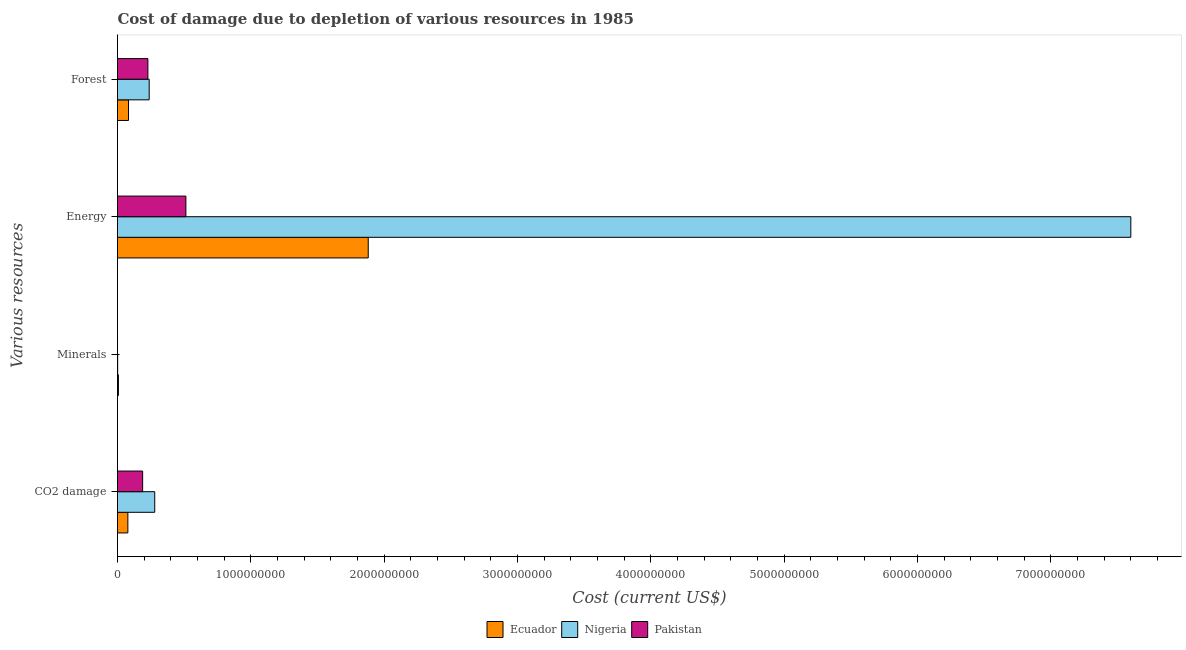How many different coloured bars are there?
Provide a succinct answer. 3. Are the number of bars per tick equal to the number of legend labels?
Your answer should be compact. Yes. Are the number of bars on each tick of the Y-axis equal?
Keep it short and to the point. Yes. What is the label of the 4th group of bars from the top?
Your answer should be very brief. CO2 damage. What is the cost of damage due to depletion of energy in Pakistan?
Offer a very short reply. 5.13e+08. Across all countries, what is the maximum cost of damage due to depletion of coal?
Your answer should be very brief. 2.79e+08. Across all countries, what is the minimum cost of damage due to depletion of forests?
Your answer should be compact. 8.26e+07. In which country was the cost of damage due to depletion of forests maximum?
Your answer should be very brief. Nigeria. What is the total cost of damage due to depletion of minerals in the graph?
Keep it short and to the point. 8.14e+06. What is the difference between the cost of damage due to depletion of minerals in Ecuador and that in Nigeria?
Offer a terse response. 5.61e+06. What is the difference between the cost of damage due to depletion of minerals in Pakistan and the cost of damage due to depletion of forests in Ecuador?
Give a very brief answer. -8.25e+07. What is the average cost of damage due to depletion of coal per country?
Provide a short and direct response. 1.82e+08. What is the difference between the cost of damage due to depletion of minerals and cost of damage due to depletion of forests in Nigeria?
Keep it short and to the point. -2.36e+08. In how many countries, is the cost of damage due to depletion of minerals greater than 2800000000 US$?
Keep it short and to the point. 0. What is the ratio of the cost of damage due to depletion of minerals in Ecuador to that in Nigeria?
Provide a short and direct response. 5.49. Is the cost of damage due to depletion of minerals in Nigeria less than that in Ecuador?
Provide a succinct answer. Yes. Is the difference between the cost of damage due to depletion of forests in Ecuador and Pakistan greater than the difference between the cost of damage due to depletion of minerals in Ecuador and Pakistan?
Provide a succinct answer. No. What is the difference between the highest and the second highest cost of damage due to depletion of minerals?
Provide a short and direct response. 5.61e+06. What is the difference between the highest and the lowest cost of damage due to depletion of energy?
Your response must be concise. 7.09e+09. In how many countries, is the cost of damage due to depletion of coal greater than the average cost of damage due to depletion of coal taken over all countries?
Your answer should be compact. 2. Is the sum of the cost of damage due to depletion of coal in Pakistan and Ecuador greater than the maximum cost of damage due to depletion of forests across all countries?
Your answer should be compact. Yes. Is it the case that in every country, the sum of the cost of damage due to depletion of forests and cost of damage due to depletion of minerals is greater than the sum of cost of damage due to depletion of coal and cost of damage due to depletion of energy?
Offer a terse response. Yes. What does the 1st bar from the top in Forest represents?
Your response must be concise. Pakistan. What does the 3rd bar from the bottom in Energy represents?
Give a very brief answer. Pakistan. Are all the bars in the graph horizontal?
Give a very brief answer. Yes. How many legend labels are there?
Give a very brief answer. 3. What is the title of the graph?
Ensure brevity in your answer.  Cost of damage due to depletion of various resources in 1985 . What is the label or title of the X-axis?
Your response must be concise. Cost (current US$). What is the label or title of the Y-axis?
Give a very brief answer. Various resources. What is the Cost (current US$) in Ecuador in CO2 damage?
Provide a short and direct response. 7.76e+07. What is the Cost (current US$) of Nigeria in CO2 damage?
Your answer should be very brief. 2.79e+08. What is the Cost (current US$) in Pakistan in CO2 damage?
Keep it short and to the point. 1.88e+08. What is the Cost (current US$) in Ecuador in Minerals?
Ensure brevity in your answer.  6.86e+06. What is the Cost (current US$) in Nigeria in Minerals?
Provide a succinct answer. 1.25e+06. What is the Cost (current US$) in Pakistan in Minerals?
Ensure brevity in your answer.  2.56e+04. What is the Cost (current US$) of Ecuador in Energy?
Offer a terse response. 1.88e+09. What is the Cost (current US$) in Nigeria in Energy?
Ensure brevity in your answer.  7.60e+09. What is the Cost (current US$) in Pakistan in Energy?
Ensure brevity in your answer.  5.13e+08. What is the Cost (current US$) of Ecuador in Forest?
Give a very brief answer. 8.26e+07. What is the Cost (current US$) of Nigeria in Forest?
Offer a very short reply. 2.38e+08. What is the Cost (current US$) in Pakistan in Forest?
Keep it short and to the point. 2.28e+08. Across all Various resources, what is the maximum Cost (current US$) in Ecuador?
Offer a very short reply. 1.88e+09. Across all Various resources, what is the maximum Cost (current US$) of Nigeria?
Make the answer very short. 7.60e+09. Across all Various resources, what is the maximum Cost (current US$) of Pakistan?
Your response must be concise. 5.13e+08. Across all Various resources, what is the minimum Cost (current US$) of Ecuador?
Make the answer very short. 6.86e+06. Across all Various resources, what is the minimum Cost (current US$) in Nigeria?
Your response must be concise. 1.25e+06. Across all Various resources, what is the minimum Cost (current US$) of Pakistan?
Your answer should be compact. 2.56e+04. What is the total Cost (current US$) in Ecuador in the graph?
Your answer should be very brief. 2.05e+09. What is the total Cost (current US$) of Nigeria in the graph?
Make the answer very short. 8.12e+09. What is the total Cost (current US$) in Pakistan in the graph?
Your response must be concise. 9.29e+08. What is the difference between the Cost (current US$) in Ecuador in CO2 damage and that in Minerals?
Make the answer very short. 7.08e+07. What is the difference between the Cost (current US$) in Nigeria in CO2 damage and that in Minerals?
Your response must be concise. 2.78e+08. What is the difference between the Cost (current US$) in Pakistan in CO2 damage and that in Minerals?
Give a very brief answer. 1.88e+08. What is the difference between the Cost (current US$) in Ecuador in CO2 damage and that in Energy?
Make the answer very short. -1.80e+09. What is the difference between the Cost (current US$) in Nigeria in CO2 damage and that in Energy?
Ensure brevity in your answer.  -7.32e+09. What is the difference between the Cost (current US$) in Pakistan in CO2 damage and that in Energy?
Your answer should be very brief. -3.24e+08. What is the difference between the Cost (current US$) in Ecuador in CO2 damage and that in Forest?
Give a very brief answer. -4.91e+06. What is the difference between the Cost (current US$) of Nigeria in CO2 damage and that in Forest?
Provide a succinct answer. 4.16e+07. What is the difference between the Cost (current US$) of Pakistan in CO2 damage and that in Forest?
Your answer should be compact. -3.94e+07. What is the difference between the Cost (current US$) in Ecuador in Minerals and that in Energy?
Your answer should be very brief. -1.87e+09. What is the difference between the Cost (current US$) in Nigeria in Minerals and that in Energy?
Your response must be concise. -7.60e+09. What is the difference between the Cost (current US$) of Pakistan in Minerals and that in Energy?
Provide a short and direct response. -5.13e+08. What is the difference between the Cost (current US$) of Ecuador in Minerals and that in Forest?
Your response must be concise. -7.57e+07. What is the difference between the Cost (current US$) of Nigeria in Minerals and that in Forest?
Give a very brief answer. -2.36e+08. What is the difference between the Cost (current US$) in Pakistan in Minerals and that in Forest?
Your answer should be very brief. -2.28e+08. What is the difference between the Cost (current US$) in Ecuador in Energy and that in Forest?
Your answer should be compact. 1.80e+09. What is the difference between the Cost (current US$) of Nigeria in Energy and that in Forest?
Your answer should be compact. 7.36e+09. What is the difference between the Cost (current US$) of Pakistan in Energy and that in Forest?
Keep it short and to the point. 2.85e+08. What is the difference between the Cost (current US$) of Ecuador in CO2 damage and the Cost (current US$) of Nigeria in Minerals?
Your answer should be very brief. 7.64e+07. What is the difference between the Cost (current US$) in Ecuador in CO2 damage and the Cost (current US$) in Pakistan in Minerals?
Your answer should be compact. 7.76e+07. What is the difference between the Cost (current US$) of Nigeria in CO2 damage and the Cost (current US$) of Pakistan in Minerals?
Your response must be concise. 2.79e+08. What is the difference between the Cost (current US$) in Ecuador in CO2 damage and the Cost (current US$) in Nigeria in Energy?
Offer a terse response. -7.52e+09. What is the difference between the Cost (current US$) of Ecuador in CO2 damage and the Cost (current US$) of Pakistan in Energy?
Offer a very short reply. -4.35e+08. What is the difference between the Cost (current US$) in Nigeria in CO2 damage and the Cost (current US$) in Pakistan in Energy?
Ensure brevity in your answer.  -2.34e+08. What is the difference between the Cost (current US$) of Ecuador in CO2 damage and the Cost (current US$) of Nigeria in Forest?
Your answer should be very brief. -1.60e+08. What is the difference between the Cost (current US$) of Ecuador in CO2 damage and the Cost (current US$) of Pakistan in Forest?
Make the answer very short. -1.50e+08. What is the difference between the Cost (current US$) of Nigeria in CO2 damage and the Cost (current US$) of Pakistan in Forest?
Offer a very short reply. 5.14e+07. What is the difference between the Cost (current US$) of Ecuador in Minerals and the Cost (current US$) of Nigeria in Energy?
Make the answer very short. -7.59e+09. What is the difference between the Cost (current US$) of Ecuador in Minerals and the Cost (current US$) of Pakistan in Energy?
Ensure brevity in your answer.  -5.06e+08. What is the difference between the Cost (current US$) in Nigeria in Minerals and the Cost (current US$) in Pakistan in Energy?
Ensure brevity in your answer.  -5.12e+08. What is the difference between the Cost (current US$) of Ecuador in Minerals and the Cost (current US$) of Nigeria in Forest?
Ensure brevity in your answer.  -2.31e+08. What is the difference between the Cost (current US$) in Ecuador in Minerals and the Cost (current US$) in Pakistan in Forest?
Offer a terse response. -2.21e+08. What is the difference between the Cost (current US$) in Nigeria in Minerals and the Cost (current US$) in Pakistan in Forest?
Provide a short and direct response. -2.27e+08. What is the difference between the Cost (current US$) of Ecuador in Energy and the Cost (current US$) of Nigeria in Forest?
Keep it short and to the point. 1.64e+09. What is the difference between the Cost (current US$) in Ecuador in Energy and the Cost (current US$) in Pakistan in Forest?
Provide a short and direct response. 1.65e+09. What is the difference between the Cost (current US$) of Nigeria in Energy and the Cost (current US$) of Pakistan in Forest?
Your answer should be compact. 7.37e+09. What is the average Cost (current US$) of Ecuador per Various resources?
Ensure brevity in your answer.  5.12e+08. What is the average Cost (current US$) in Nigeria per Various resources?
Give a very brief answer. 2.03e+09. What is the average Cost (current US$) of Pakistan per Various resources?
Provide a succinct answer. 2.32e+08. What is the difference between the Cost (current US$) of Ecuador and Cost (current US$) of Nigeria in CO2 damage?
Provide a short and direct response. -2.02e+08. What is the difference between the Cost (current US$) in Ecuador and Cost (current US$) in Pakistan in CO2 damage?
Provide a short and direct response. -1.11e+08. What is the difference between the Cost (current US$) in Nigeria and Cost (current US$) in Pakistan in CO2 damage?
Offer a terse response. 9.08e+07. What is the difference between the Cost (current US$) in Ecuador and Cost (current US$) in Nigeria in Minerals?
Keep it short and to the point. 5.61e+06. What is the difference between the Cost (current US$) of Ecuador and Cost (current US$) of Pakistan in Minerals?
Provide a succinct answer. 6.83e+06. What is the difference between the Cost (current US$) in Nigeria and Cost (current US$) in Pakistan in Minerals?
Make the answer very short. 1.22e+06. What is the difference between the Cost (current US$) of Ecuador and Cost (current US$) of Nigeria in Energy?
Make the answer very short. -5.72e+09. What is the difference between the Cost (current US$) in Ecuador and Cost (current US$) in Pakistan in Energy?
Provide a short and direct response. 1.37e+09. What is the difference between the Cost (current US$) of Nigeria and Cost (current US$) of Pakistan in Energy?
Your answer should be compact. 7.09e+09. What is the difference between the Cost (current US$) of Ecuador and Cost (current US$) of Nigeria in Forest?
Make the answer very short. -1.55e+08. What is the difference between the Cost (current US$) in Ecuador and Cost (current US$) in Pakistan in Forest?
Make the answer very short. -1.45e+08. What is the difference between the Cost (current US$) of Nigeria and Cost (current US$) of Pakistan in Forest?
Provide a short and direct response. 9.81e+06. What is the ratio of the Cost (current US$) of Ecuador in CO2 damage to that in Minerals?
Offer a terse response. 11.32. What is the ratio of the Cost (current US$) of Nigeria in CO2 damage to that in Minerals?
Keep it short and to the point. 223.34. What is the ratio of the Cost (current US$) of Pakistan in CO2 damage to that in Minerals?
Ensure brevity in your answer.  7361.03. What is the ratio of the Cost (current US$) of Ecuador in CO2 damage to that in Energy?
Offer a very short reply. 0.04. What is the ratio of the Cost (current US$) in Nigeria in CO2 damage to that in Energy?
Make the answer very short. 0.04. What is the ratio of the Cost (current US$) in Pakistan in CO2 damage to that in Energy?
Offer a terse response. 0.37. What is the ratio of the Cost (current US$) in Ecuador in CO2 damage to that in Forest?
Your answer should be very brief. 0.94. What is the ratio of the Cost (current US$) of Nigeria in CO2 damage to that in Forest?
Ensure brevity in your answer.  1.18. What is the ratio of the Cost (current US$) of Pakistan in CO2 damage to that in Forest?
Keep it short and to the point. 0.83. What is the ratio of the Cost (current US$) in Ecuador in Minerals to that in Energy?
Make the answer very short. 0. What is the ratio of the Cost (current US$) of Ecuador in Minerals to that in Forest?
Provide a short and direct response. 0.08. What is the ratio of the Cost (current US$) in Nigeria in Minerals to that in Forest?
Your answer should be compact. 0.01. What is the ratio of the Cost (current US$) of Pakistan in Minerals to that in Forest?
Give a very brief answer. 0. What is the ratio of the Cost (current US$) in Ecuador in Energy to that in Forest?
Give a very brief answer. 22.78. What is the ratio of the Cost (current US$) of Nigeria in Energy to that in Forest?
Provide a short and direct response. 31.98. What is the ratio of the Cost (current US$) of Pakistan in Energy to that in Forest?
Your answer should be compact. 2.25. What is the difference between the highest and the second highest Cost (current US$) of Ecuador?
Your answer should be compact. 1.80e+09. What is the difference between the highest and the second highest Cost (current US$) in Nigeria?
Your answer should be compact. 7.32e+09. What is the difference between the highest and the second highest Cost (current US$) of Pakistan?
Provide a succinct answer. 2.85e+08. What is the difference between the highest and the lowest Cost (current US$) of Ecuador?
Ensure brevity in your answer.  1.87e+09. What is the difference between the highest and the lowest Cost (current US$) in Nigeria?
Give a very brief answer. 7.60e+09. What is the difference between the highest and the lowest Cost (current US$) in Pakistan?
Your response must be concise. 5.13e+08. 